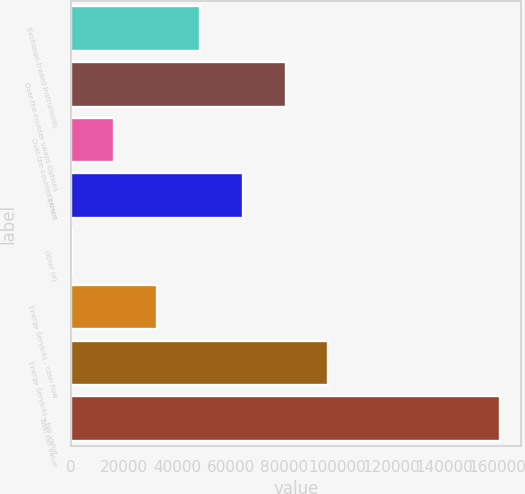Convert chart to OTSL. <chart><loc_0><loc_0><loc_500><loc_500><bar_chart><fcel>Exchange-traded instruments<fcel>Over-the-counter swaps Options<fcel>Over-the-counter swaps<fcel>Options<fcel>Other (a)<fcel>Energy Services - cash flow<fcel>Energy Services - fair value<fcel>Total fair value<nl><fcel>48430.1<fcel>80525.5<fcel>16334.7<fcel>64477.8<fcel>287<fcel>32382.4<fcel>96573.2<fcel>160764<nl></chart> 